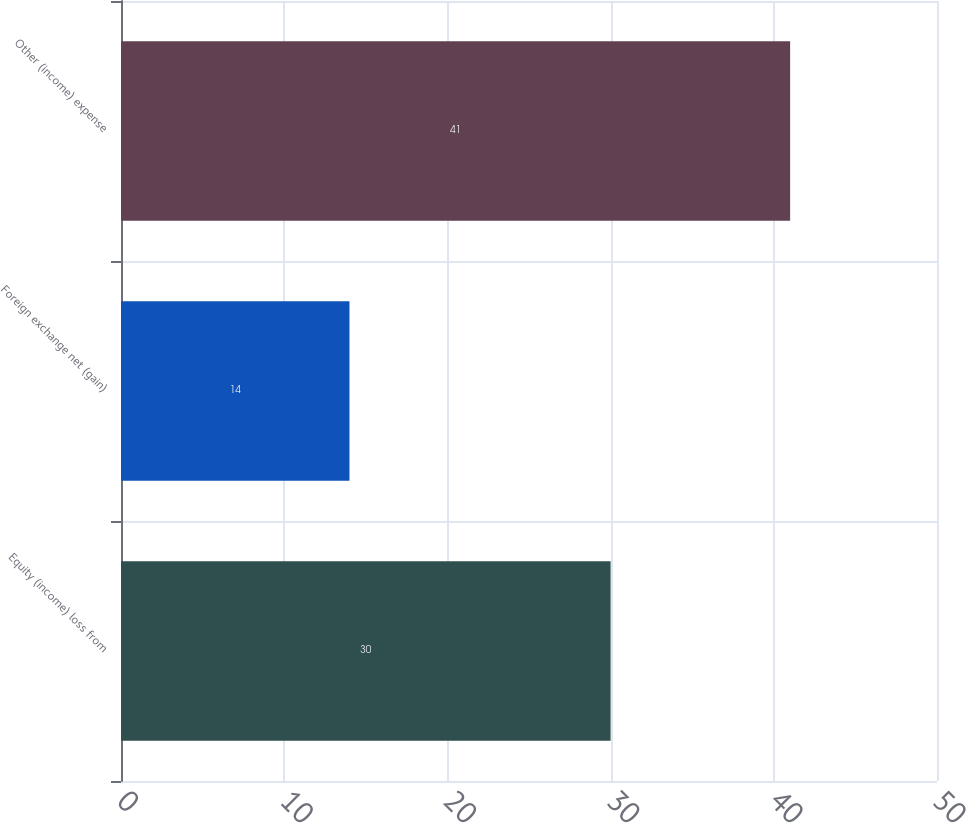Convert chart. <chart><loc_0><loc_0><loc_500><loc_500><bar_chart><fcel>Equity (income) loss from<fcel>Foreign exchange net (gain)<fcel>Other (income) expense<nl><fcel>30<fcel>14<fcel>41<nl></chart> 